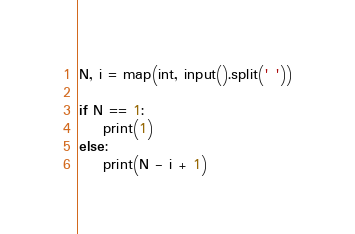<code> <loc_0><loc_0><loc_500><loc_500><_Python_>N, i = map(int, input().split(' '))

if N == 1:
    print(1)
else:
    print(N - i + 1)</code> 